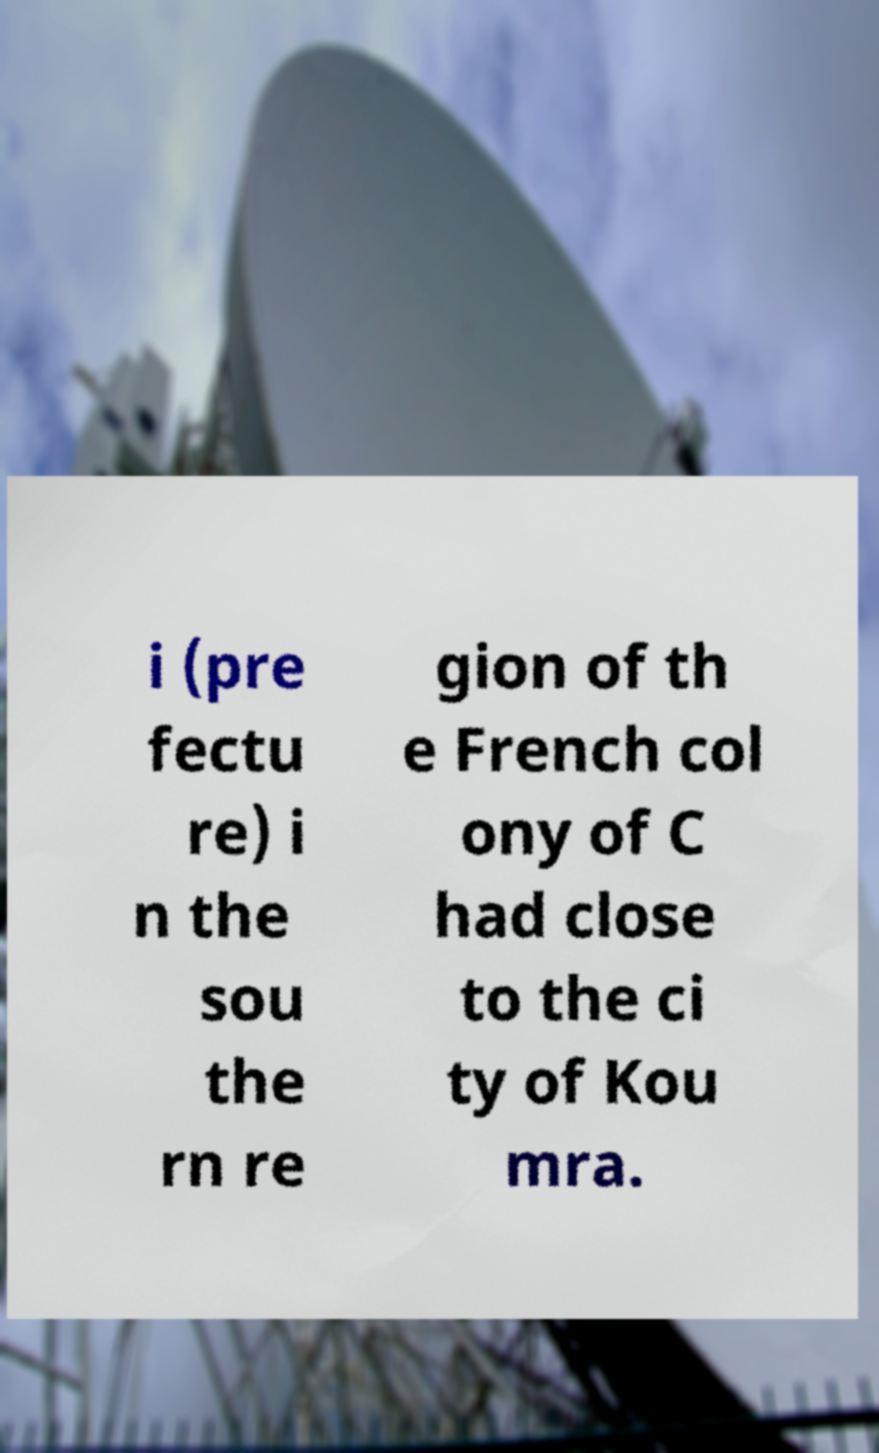Can you read and provide the text displayed in the image?This photo seems to have some interesting text. Can you extract and type it out for me? i (pre fectu re) i n the sou the rn re gion of th e French col ony of C had close to the ci ty of Kou mra. 